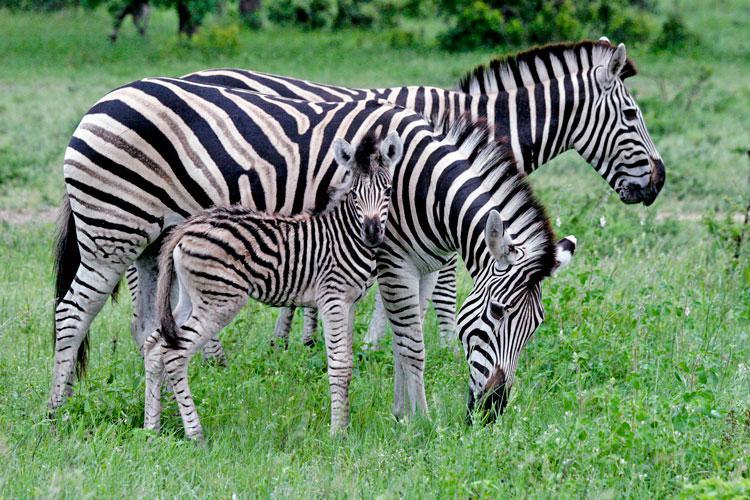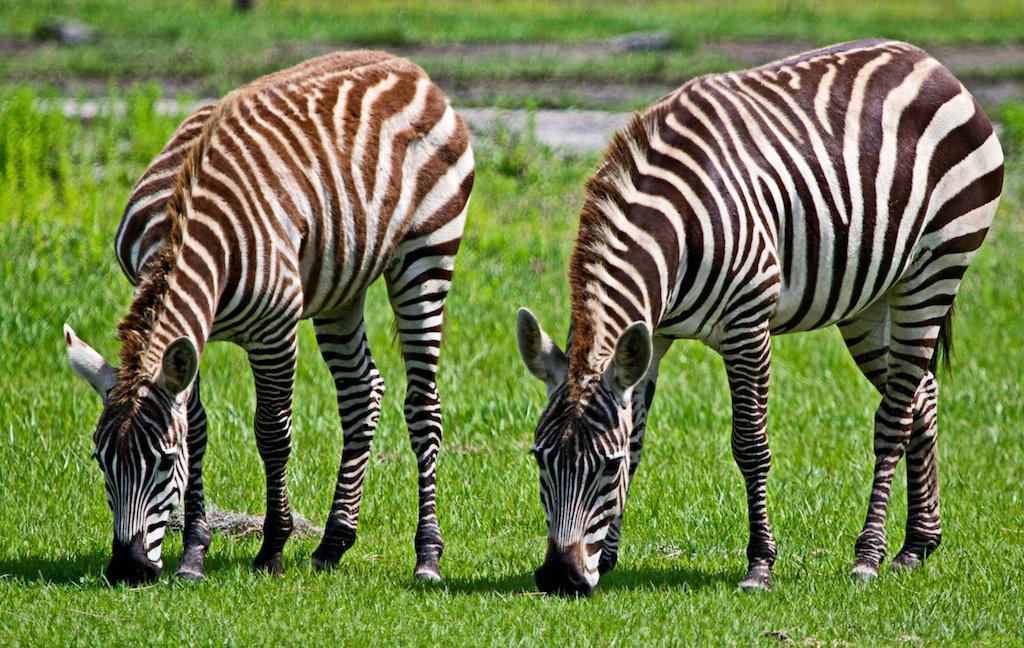The first image is the image on the left, the second image is the image on the right. Examine the images to the left and right. Is the description "A baby zebra is shown nursing in one image." accurate? Answer yes or no. No. The first image is the image on the left, the second image is the image on the right. Assess this claim about the two images: "There is a baby zebra eating from its mother zebra.". Correct or not? Answer yes or no. No. 